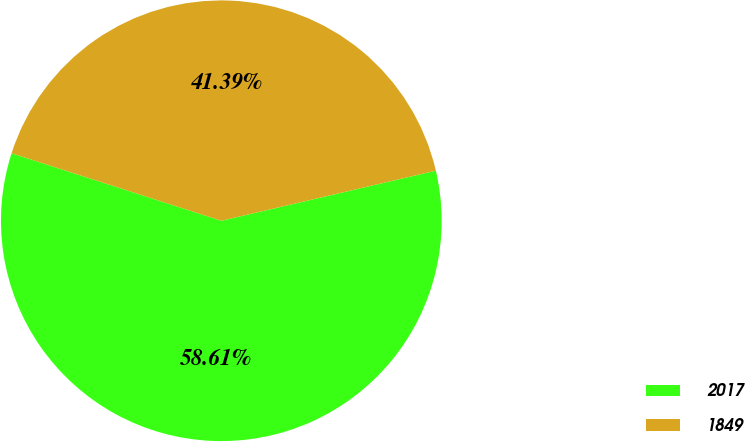Convert chart. <chart><loc_0><loc_0><loc_500><loc_500><pie_chart><fcel>2017<fcel>1849<nl><fcel>58.61%<fcel>41.39%<nl></chart> 